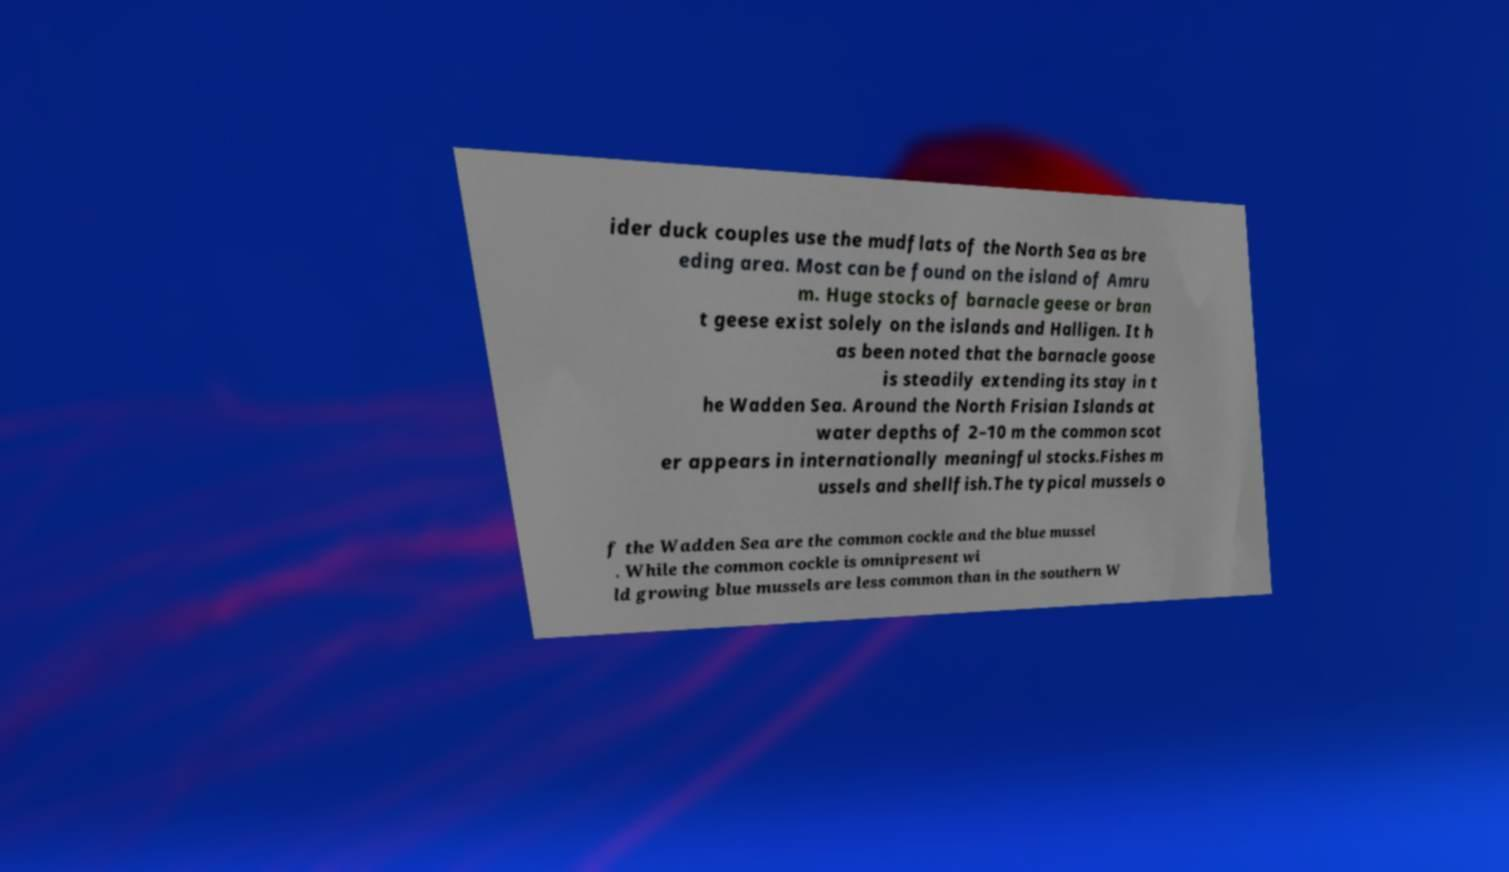There's text embedded in this image that I need extracted. Can you transcribe it verbatim? ider duck couples use the mudflats of the North Sea as bre eding area. Most can be found on the island of Amru m. Huge stocks of barnacle geese or bran t geese exist solely on the islands and Halligen. It h as been noted that the barnacle goose is steadily extending its stay in t he Wadden Sea. Around the North Frisian Islands at water depths of 2–10 m the common scot er appears in internationally meaningful stocks.Fishes m ussels and shellfish.The typical mussels o f the Wadden Sea are the common cockle and the blue mussel . While the common cockle is omnipresent wi ld growing blue mussels are less common than in the southern W 